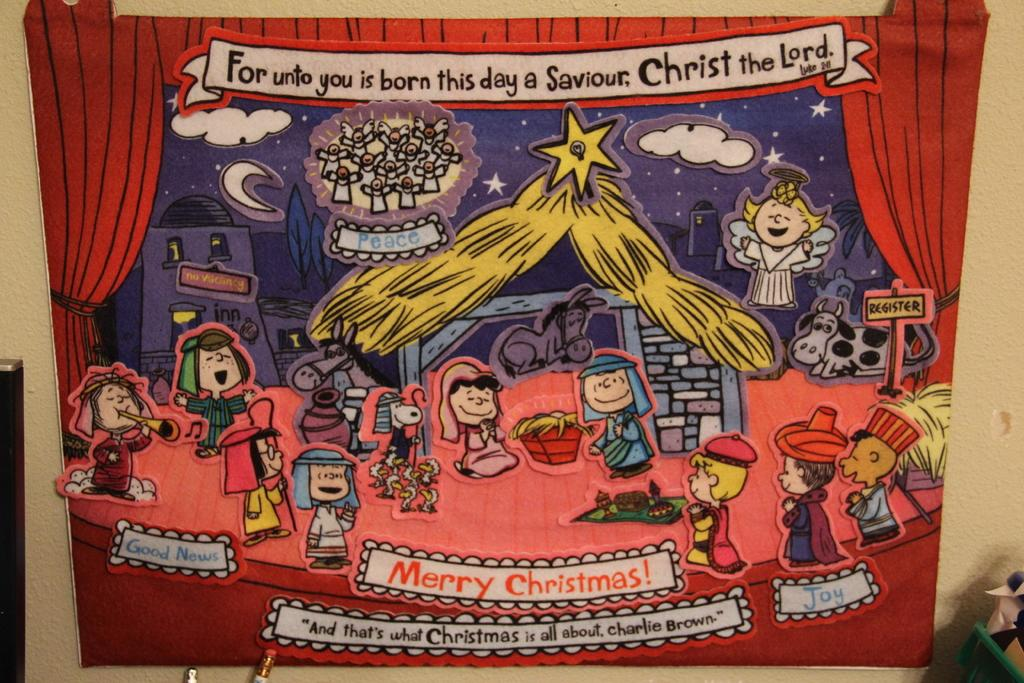<image>
Describe the image concisely. An illustrated scene that has Merry Christmas at the bottom of the page 